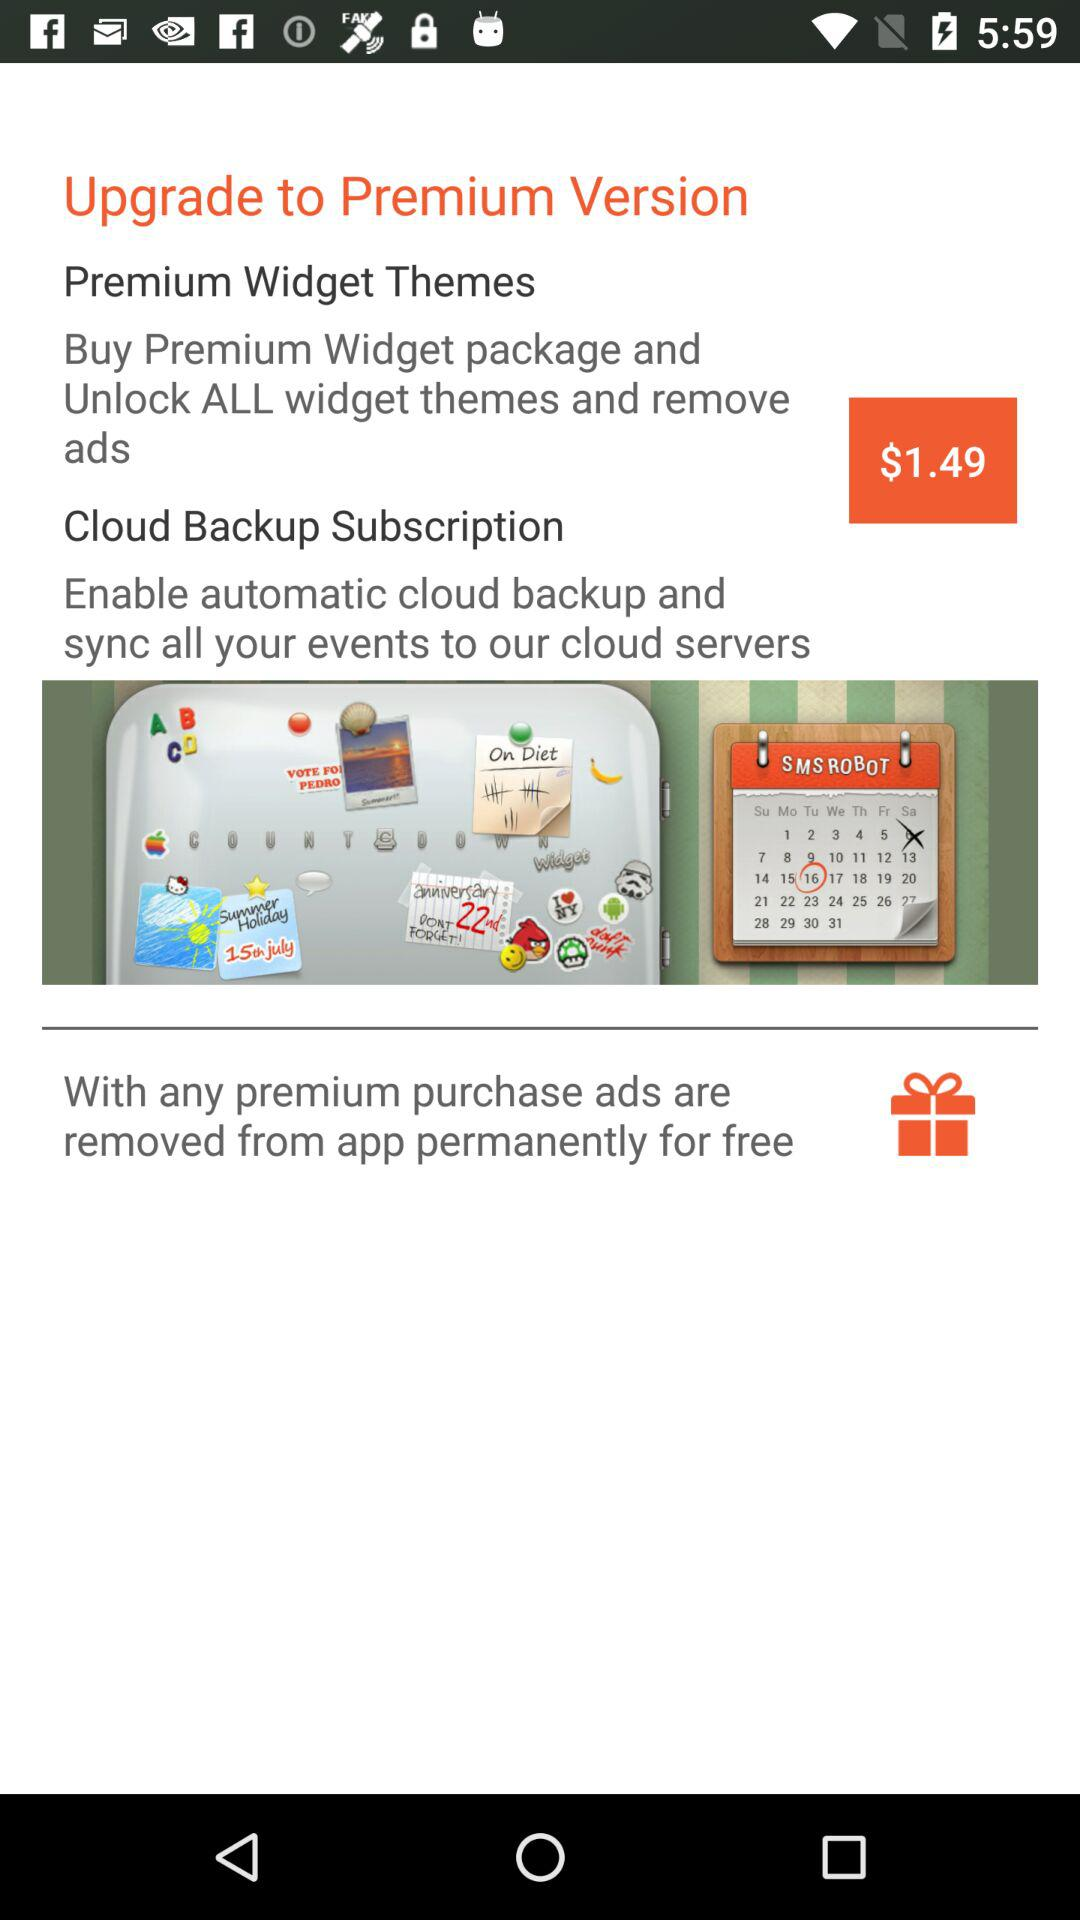What is the price to upgrade to the premium version? The price is $1.49. 